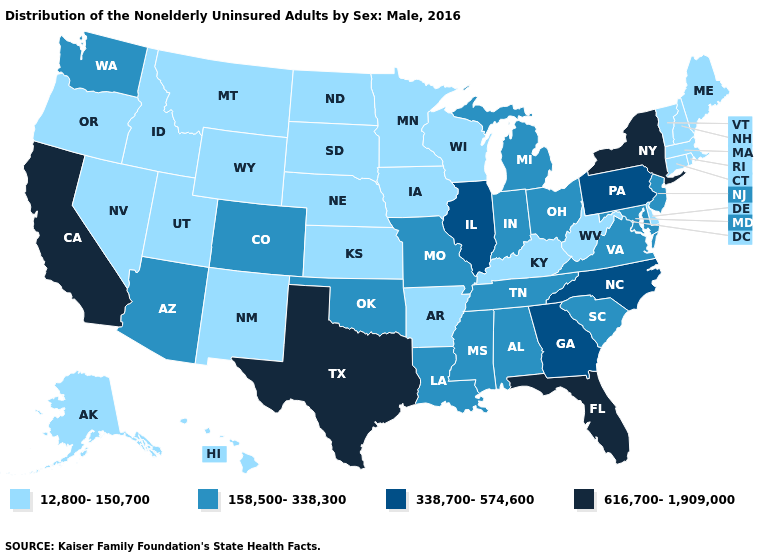Which states hav the highest value in the MidWest?
Be succinct. Illinois. Does Utah have the lowest value in the West?
Keep it brief. Yes. What is the value of Arkansas?
Quick response, please. 12,800-150,700. What is the highest value in the Northeast ?
Short answer required. 616,700-1,909,000. Name the states that have a value in the range 338,700-574,600?
Answer briefly. Georgia, Illinois, North Carolina, Pennsylvania. Name the states that have a value in the range 338,700-574,600?
Be succinct. Georgia, Illinois, North Carolina, Pennsylvania. Does New Hampshire have a higher value than North Dakota?
Give a very brief answer. No. What is the value of Montana?
Quick response, please. 12,800-150,700. What is the highest value in the West ?
Concise answer only. 616,700-1,909,000. What is the value of Tennessee?
Answer briefly. 158,500-338,300. Name the states that have a value in the range 338,700-574,600?
Answer briefly. Georgia, Illinois, North Carolina, Pennsylvania. What is the lowest value in the Northeast?
Write a very short answer. 12,800-150,700. What is the value of Wyoming?
Write a very short answer. 12,800-150,700. What is the value of Ohio?
Give a very brief answer. 158,500-338,300. Does Missouri have the lowest value in the MidWest?
Write a very short answer. No. 